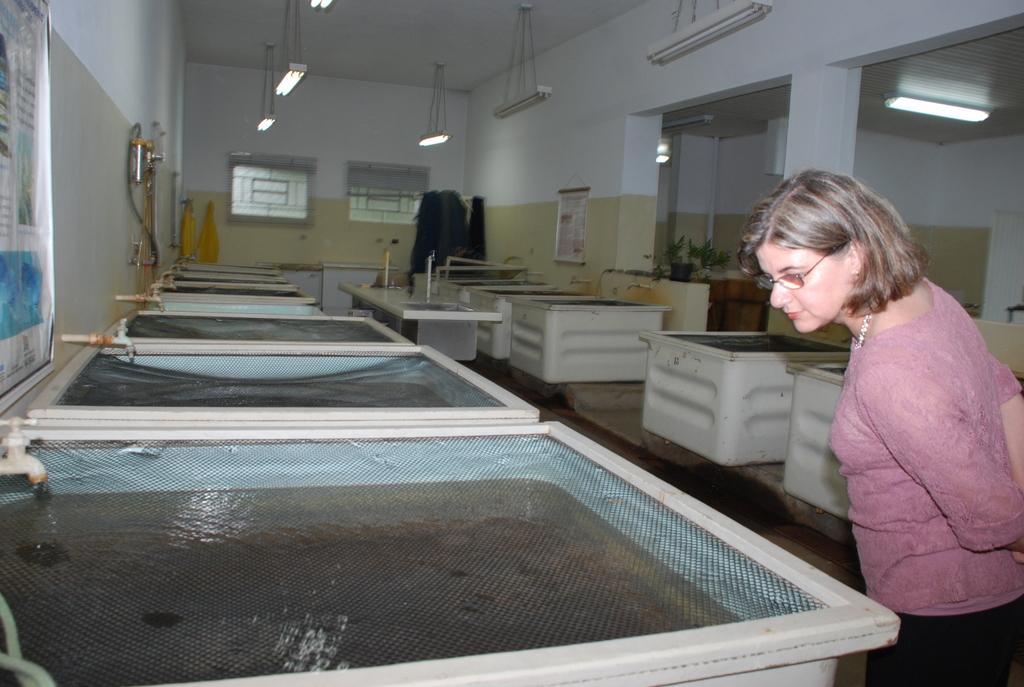How would you summarize this image in a sentence or two? In this picture we can see a woman is standing on the floor. In front of the women there are some containers with water. On the left side of the containers there is a wall with tape, a banner and some objects. On the right side of the containers there is a houseplant. At the top there are lights hanged to the ceiling. 